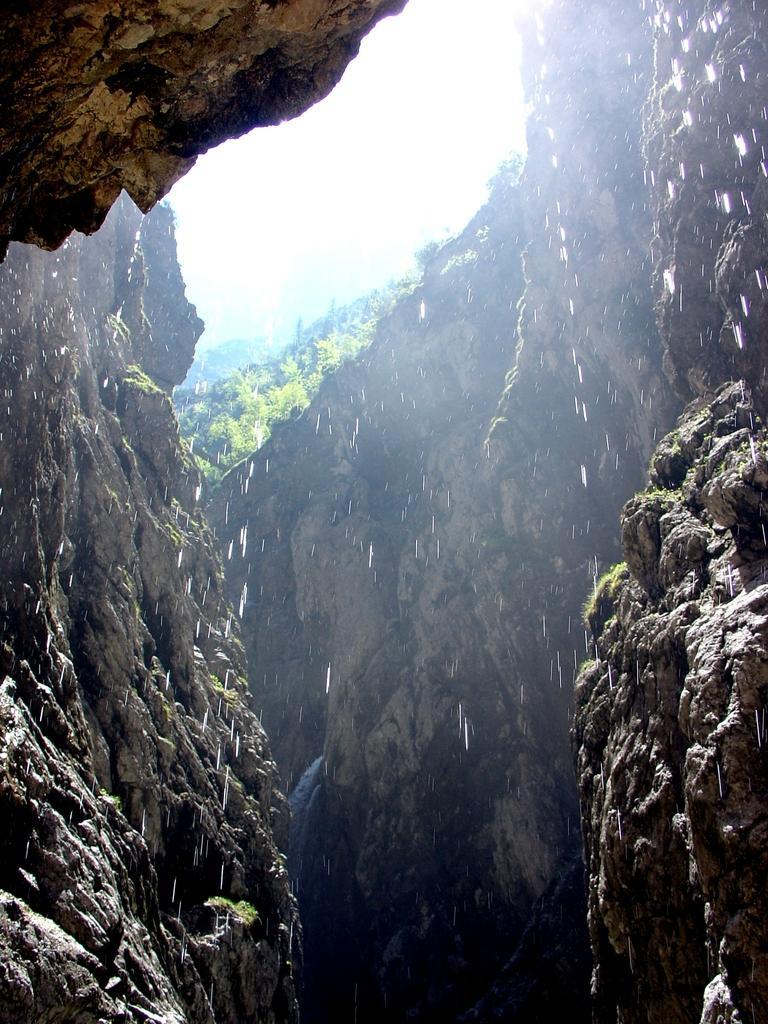Can you describe this image briefly? In this image I can see the rock, background I can see plants in green color and the sky is in white color. 